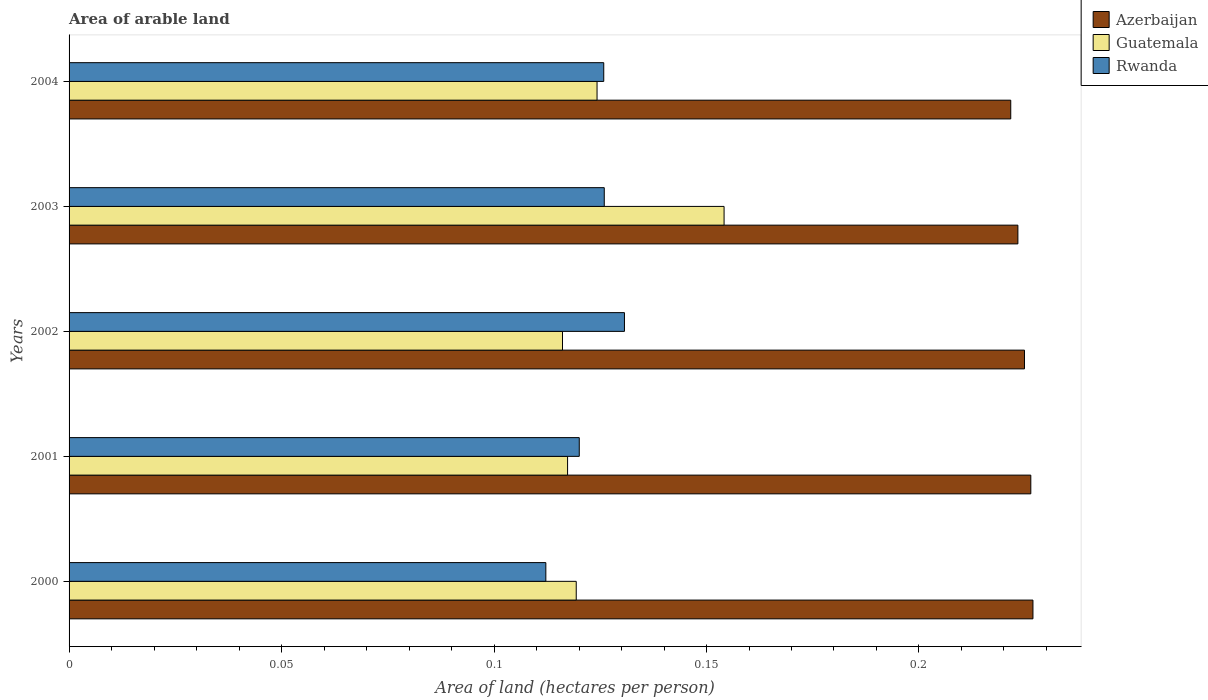How many different coloured bars are there?
Offer a terse response. 3. How many groups of bars are there?
Ensure brevity in your answer.  5. Are the number of bars per tick equal to the number of legend labels?
Give a very brief answer. Yes. Are the number of bars on each tick of the Y-axis equal?
Your answer should be very brief. Yes. How many bars are there on the 5th tick from the top?
Your answer should be very brief. 3. How many bars are there on the 5th tick from the bottom?
Offer a very short reply. 3. In how many cases, is the number of bars for a given year not equal to the number of legend labels?
Give a very brief answer. 0. What is the total arable land in Guatemala in 2001?
Keep it short and to the point. 0.12. Across all years, what is the maximum total arable land in Rwanda?
Keep it short and to the point. 0.13. Across all years, what is the minimum total arable land in Guatemala?
Offer a very short reply. 0.12. In which year was the total arable land in Guatemala minimum?
Offer a terse response. 2002. What is the total total arable land in Azerbaijan in the graph?
Offer a terse response. 1.12. What is the difference between the total arable land in Rwanda in 2000 and that in 2004?
Provide a succinct answer. -0.01. What is the difference between the total arable land in Rwanda in 2004 and the total arable land in Azerbaijan in 2001?
Provide a succinct answer. -0.1. What is the average total arable land in Guatemala per year?
Offer a terse response. 0.13. In the year 2004, what is the difference between the total arable land in Rwanda and total arable land in Azerbaijan?
Your response must be concise. -0.1. In how many years, is the total arable land in Azerbaijan greater than 0.12000000000000001 hectares per person?
Your answer should be very brief. 5. What is the ratio of the total arable land in Guatemala in 2000 to that in 2003?
Offer a very short reply. 0.77. Is the difference between the total arable land in Rwanda in 2000 and 2002 greater than the difference between the total arable land in Azerbaijan in 2000 and 2002?
Ensure brevity in your answer.  No. What is the difference between the highest and the second highest total arable land in Azerbaijan?
Your response must be concise. 0. What is the difference between the highest and the lowest total arable land in Guatemala?
Your answer should be compact. 0.04. Is the sum of the total arable land in Guatemala in 2000 and 2001 greater than the maximum total arable land in Rwanda across all years?
Give a very brief answer. Yes. What does the 2nd bar from the top in 2001 represents?
Your response must be concise. Guatemala. What does the 2nd bar from the bottom in 2001 represents?
Your answer should be compact. Guatemala. Is it the case that in every year, the sum of the total arable land in Azerbaijan and total arable land in Rwanda is greater than the total arable land in Guatemala?
Provide a succinct answer. Yes. How many bars are there?
Keep it short and to the point. 15. Are all the bars in the graph horizontal?
Offer a very short reply. Yes. What is the difference between two consecutive major ticks on the X-axis?
Give a very brief answer. 0.05. Does the graph contain any zero values?
Provide a short and direct response. No. Does the graph contain grids?
Your response must be concise. No. Where does the legend appear in the graph?
Provide a succinct answer. Top right. How are the legend labels stacked?
Provide a succinct answer. Vertical. What is the title of the graph?
Offer a terse response. Area of arable land. Does "Sierra Leone" appear as one of the legend labels in the graph?
Offer a terse response. No. What is the label or title of the X-axis?
Your answer should be very brief. Area of land (hectares per person). What is the Area of land (hectares per person) of Azerbaijan in 2000?
Give a very brief answer. 0.23. What is the Area of land (hectares per person) in Guatemala in 2000?
Your answer should be very brief. 0.12. What is the Area of land (hectares per person) of Rwanda in 2000?
Ensure brevity in your answer.  0.11. What is the Area of land (hectares per person) in Azerbaijan in 2001?
Offer a terse response. 0.23. What is the Area of land (hectares per person) in Guatemala in 2001?
Ensure brevity in your answer.  0.12. What is the Area of land (hectares per person) in Rwanda in 2001?
Ensure brevity in your answer.  0.12. What is the Area of land (hectares per person) of Azerbaijan in 2002?
Your response must be concise. 0.22. What is the Area of land (hectares per person) of Guatemala in 2002?
Provide a short and direct response. 0.12. What is the Area of land (hectares per person) of Rwanda in 2002?
Provide a short and direct response. 0.13. What is the Area of land (hectares per person) in Azerbaijan in 2003?
Your answer should be compact. 0.22. What is the Area of land (hectares per person) of Guatemala in 2003?
Your response must be concise. 0.15. What is the Area of land (hectares per person) in Rwanda in 2003?
Your answer should be very brief. 0.13. What is the Area of land (hectares per person) in Azerbaijan in 2004?
Provide a short and direct response. 0.22. What is the Area of land (hectares per person) in Guatemala in 2004?
Offer a terse response. 0.12. What is the Area of land (hectares per person) of Rwanda in 2004?
Provide a succinct answer. 0.13. Across all years, what is the maximum Area of land (hectares per person) of Azerbaijan?
Provide a short and direct response. 0.23. Across all years, what is the maximum Area of land (hectares per person) of Guatemala?
Your answer should be compact. 0.15. Across all years, what is the maximum Area of land (hectares per person) in Rwanda?
Offer a very short reply. 0.13. Across all years, what is the minimum Area of land (hectares per person) of Azerbaijan?
Offer a terse response. 0.22. Across all years, what is the minimum Area of land (hectares per person) of Guatemala?
Your answer should be very brief. 0.12. Across all years, what is the minimum Area of land (hectares per person) of Rwanda?
Keep it short and to the point. 0.11. What is the total Area of land (hectares per person) in Azerbaijan in the graph?
Your response must be concise. 1.12. What is the total Area of land (hectares per person) of Guatemala in the graph?
Ensure brevity in your answer.  0.63. What is the total Area of land (hectares per person) in Rwanda in the graph?
Offer a very short reply. 0.61. What is the difference between the Area of land (hectares per person) in Azerbaijan in 2000 and that in 2001?
Make the answer very short. 0. What is the difference between the Area of land (hectares per person) in Guatemala in 2000 and that in 2001?
Your response must be concise. 0. What is the difference between the Area of land (hectares per person) in Rwanda in 2000 and that in 2001?
Make the answer very short. -0.01. What is the difference between the Area of land (hectares per person) in Azerbaijan in 2000 and that in 2002?
Provide a succinct answer. 0. What is the difference between the Area of land (hectares per person) of Guatemala in 2000 and that in 2002?
Give a very brief answer. 0. What is the difference between the Area of land (hectares per person) in Rwanda in 2000 and that in 2002?
Keep it short and to the point. -0.02. What is the difference between the Area of land (hectares per person) in Azerbaijan in 2000 and that in 2003?
Provide a short and direct response. 0. What is the difference between the Area of land (hectares per person) in Guatemala in 2000 and that in 2003?
Provide a short and direct response. -0.03. What is the difference between the Area of land (hectares per person) of Rwanda in 2000 and that in 2003?
Give a very brief answer. -0.01. What is the difference between the Area of land (hectares per person) in Azerbaijan in 2000 and that in 2004?
Your answer should be very brief. 0.01. What is the difference between the Area of land (hectares per person) in Guatemala in 2000 and that in 2004?
Provide a succinct answer. -0. What is the difference between the Area of land (hectares per person) in Rwanda in 2000 and that in 2004?
Make the answer very short. -0.01. What is the difference between the Area of land (hectares per person) of Azerbaijan in 2001 and that in 2002?
Ensure brevity in your answer.  0. What is the difference between the Area of land (hectares per person) of Guatemala in 2001 and that in 2002?
Your answer should be very brief. 0. What is the difference between the Area of land (hectares per person) of Rwanda in 2001 and that in 2002?
Your response must be concise. -0.01. What is the difference between the Area of land (hectares per person) in Azerbaijan in 2001 and that in 2003?
Offer a terse response. 0. What is the difference between the Area of land (hectares per person) of Guatemala in 2001 and that in 2003?
Offer a very short reply. -0.04. What is the difference between the Area of land (hectares per person) in Rwanda in 2001 and that in 2003?
Offer a terse response. -0.01. What is the difference between the Area of land (hectares per person) in Azerbaijan in 2001 and that in 2004?
Your answer should be compact. 0. What is the difference between the Area of land (hectares per person) of Guatemala in 2001 and that in 2004?
Your answer should be compact. -0.01. What is the difference between the Area of land (hectares per person) in Rwanda in 2001 and that in 2004?
Offer a very short reply. -0.01. What is the difference between the Area of land (hectares per person) of Azerbaijan in 2002 and that in 2003?
Provide a short and direct response. 0. What is the difference between the Area of land (hectares per person) of Guatemala in 2002 and that in 2003?
Give a very brief answer. -0.04. What is the difference between the Area of land (hectares per person) in Rwanda in 2002 and that in 2003?
Your answer should be compact. 0. What is the difference between the Area of land (hectares per person) in Azerbaijan in 2002 and that in 2004?
Keep it short and to the point. 0. What is the difference between the Area of land (hectares per person) in Guatemala in 2002 and that in 2004?
Your answer should be very brief. -0.01. What is the difference between the Area of land (hectares per person) in Rwanda in 2002 and that in 2004?
Your answer should be compact. 0. What is the difference between the Area of land (hectares per person) of Azerbaijan in 2003 and that in 2004?
Keep it short and to the point. 0. What is the difference between the Area of land (hectares per person) in Guatemala in 2003 and that in 2004?
Your answer should be compact. 0.03. What is the difference between the Area of land (hectares per person) in Rwanda in 2003 and that in 2004?
Your answer should be very brief. 0. What is the difference between the Area of land (hectares per person) of Azerbaijan in 2000 and the Area of land (hectares per person) of Guatemala in 2001?
Offer a terse response. 0.11. What is the difference between the Area of land (hectares per person) in Azerbaijan in 2000 and the Area of land (hectares per person) in Rwanda in 2001?
Your answer should be very brief. 0.11. What is the difference between the Area of land (hectares per person) of Guatemala in 2000 and the Area of land (hectares per person) of Rwanda in 2001?
Provide a succinct answer. -0. What is the difference between the Area of land (hectares per person) in Azerbaijan in 2000 and the Area of land (hectares per person) in Guatemala in 2002?
Make the answer very short. 0.11. What is the difference between the Area of land (hectares per person) of Azerbaijan in 2000 and the Area of land (hectares per person) of Rwanda in 2002?
Ensure brevity in your answer.  0.1. What is the difference between the Area of land (hectares per person) of Guatemala in 2000 and the Area of land (hectares per person) of Rwanda in 2002?
Your response must be concise. -0.01. What is the difference between the Area of land (hectares per person) in Azerbaijan in 2000 and the Area of land (hectares per person) in Guatemala in 2003?
Your response must be concise. 0.07. What is the difference between the Area of land (hectares per person) of Azerbaijan in 2000 and the Area of land (hectares per person) of Rwanda in 2003?
Offer a terse response. 0.1. What is the difference between the Area of land (hectares per person) of Guatemala in 2000 and the Area of land (hectares per person) of Rwanda in 2003?
Provide a succinct answer. -0.01. What is the difference between the Area of land (hectares per person) in Azerbaijan in 2000 and the Area of land (hectares per person) in Guatemala in 2004?
Ensure brevity in your answer.  0.1. What is the difference between the Area of land (hectares per person) in Azerbaijan in 2000 and the Area of land (hectares per person) in Rwanda in 2004?
Provide a short and direct response. 0.1. What is the difference between the Area of land (hectares per person) in Guatemala in 2000 and the Area of land (hectares per person) in Rwanda in 2004?
Keep it short and to the point. -0.01. What is the difference between the Area of land (hectares per person) in Azerbaijan in 2001 and the Area of land (hectares per person) in Guatemala in 2002?
Provide a succinct answer. 0.11. What is the difference between the Area of land (hectares per person) in Azerbaijan in 2001 and the Area of land (hectares per person) in Rwanda in 2002?
Provide a short and direct response. 0.1. What is the difference between the Area of land (hectares per person) of Guatemala in 2001 and the Area of land (hectares per person) of Rwanda in 2002?
Make the answer very short. -0.01. What is the difference between the Area of land (hectares per person) in Azerbaijan in 2001 and the Area of land (hectares per person) in Guatemala in 2003?
Your response must be concise. 0.07. What is the difference between the Area of land (hectares per person) of Azerbaijan in 2001 and the Area of land (hectares per person) of Rwanda in 2003?
Your response must be concise. 0.1. What is the difference between the Area of land (hectares per person) in Guatemala in 2001 and the Area of land (hectares per person) in Rwanda in 2003?
Make the answer very short. -0.01. What is the difference between the Area of land (hectares per person) of Azerbaijan in 2001 and the Area of land (hectares per person) of Guatemala in 2004?
Provide a succinct answer. 0.1. What is the difference between the Area of land (hectares per person) of Azerbaijan in 2001 and the Area of land (hectares per person) of Rwanda in 2004?
Offer a terse response. 0.1. What is the difference between the Area of land (hectares per person) of Guatemala in 2001 and the Area of land (hectares per person) of Rwanda in 2004?
Your response must be concise. -0.01. What is the difference between the Area of land (hectares per person) of Azerbaijan in 2002 and the Area of land (hectares per person) of Guatemala in 2003?
Your response must be concise. 0.07. What is the difference between the Area of land (hectares per person) of Azerbaijan in 2002 and the Area of land (hectares per person) of Rwanda in 2003?
Your response must be concise. 0.1. What is the difference between the Area of land (hectares per person) in Guatemala in 2002 and the Area of land (hectares per person) in Rwanda in 2003?
Your answer should be very brief. -0.01. What is the difference between the Area of land (hectares per person) of Azerbaijan in 2002 and the Area of land (hectares per person) of Guatemala in 2004?
Give a very brief answer. 0.1. What is the difference between the Area of land (hectares per person) in Azerbaijan in 2002 and the Area of land (hectares per person) in Rwanda in 2004?
Provide a succinct answer. 0.1. What is the difference between the Area of land (hectares per person) in Guatemala in 2002 and the Area of land (hectares per person) in Rwanda in 2004?
Your answer should be compact. -0.01. What is the difference between the Area of land (hectares per person) of Azerbaijan in 2003 and the Area of land (hectares per person) of Guatemala in 2004?
Provide a succinct answer. 0.1. What is the difference between the Area of land (hectares per person) in Azerbaijan in 2003 and the Area of land (hectares per person) in Rwanda in 2004?
Your answer should be very brief. 0.1. What is the difference between the Area of land (hectares per person) in Guatemala in 2003 and the Area of land (hectares per person) in Rwanda in 2004?
Your answer should be compact. 0.03. What is the average Area of land (hectares per person) of Azerbaijan per year?
Your answer should be compact. 0.22. What is the average Area of land (hectares per person) in Guatemala per year?
Offer a terse response. 0.13. What is the average Area of land (hectares per person) in Rwanda per year?
Offer a terse response. 0.12. In the year 2000, what is the difference between the Area of land (hectares per person) of Azerbaijan and Area of land (hectares per person) of Guatemala?
Your response must be concise. 0.11. In the year 2000, what is the difference between the Area of land (hectares per person) in Azerbaijan and Area of land (hectares per person) in Rwanda?
Offer a terse response. 0.11. In the year 2000, what is the difference between the Area of land (hectares per person) in Guatemala and Area of land (hectares per person) in Rwanda?
Provide a short and direct response. 0.01. In the year 2001, what is the difference between the Area of land (hectares per person) of Azerbaijan and Area of land (hectares per person) of Guatemala?
Your answer should be very brief. 0.11. In the year 2001, what is the difference between the Area of land (hectares per person) in Azerbaijan and Area of land (hectares per person) in Rwanda?
Ensure brevity in your answer.  0.11. In the year 2001, what is the difference between the Area of land (hectares per person) in Guatemala and Area of land (hectares per person) in Rwanda?
Your answer should be compact. -0. In the year 2002, what is the difference between the Area of land (hectares per person) in Azerbaijan and Area of land (hectares per person) in Guatemala?
Your answer should be very brief. 0.11. In the year 2002, what is the difference between the Area of land (hectares per person) of Azerbaijan and Area of land (hectares per person) of Rwanda?
Your response must be concise. 0.09. In the year 2002, what is the difference between the Area of land (hectares per person) of Guatemala and Area of land (hectares per person) of Rwanda?
Give a very brief answer. -0.01. In the year 2003, what is the difference between the Area of land (hectares per person) in Azerbaijan and Area of land (hectares per person) in Guatemala?
Provide a succinct answer. 0.07. In the year 2003, what is the difference between the Area of land (hectares per person) in Azerbaijan and Area of land (hectares per person) in Rwanda?
Provide a short and direct response. 0.1. In the year 2003, what is the difference between the Area of land (hectares per person) in Guatemala and Area of land (hectares per person) in Rwanda?
Provide a short and direct response. 0.03. In the year 2004, what is the difference between the Area of land (hectares per person) of Azerbaijan and Area of land (hectares per person) of Guatemala?
Offer a terse response. 0.1. In the year 2004, what is the difference between the Area of land (hectares per person) of Azerbaijan and Area of land (hectares per person) of Rwanda?
Your response must be concise. 0.1. In the year 2004, what is the difference between the Area of land (hectares per person) in Guatemala and Area of land (hectares per person) in Rwanda?
Provide a short and direct response. -0. What is the ratio of the Area of land (hectares per person) of Guatemala in 2000 to that in 2001?
Provide a short and direct response. 1.02. What is the ratio of the Area of land (hectares per person) of Rwanda in 2000 to that in 2001?
Keep it short and to the point. 0.93. What is the ratio of the Area of land (hectares per person) in Azerbaijan in 2000 to that in 2002?
Your answer should be compact. 1.01. What is the ratio of the Area of land (hectares per person) of Guatemala in 2000 to that in 2002?
Give a very brief answer. 1.03. What is the ratio of the Area of land (hectares per person) of Rwanda in 2000 to that in 2002?
Your answer should be compact. 0.86. What is the ratio of the Area of land (hectares per person) in Azerbaijan in 2000 to that in 2003?
Your response must be concise. 1.02. What is the ratio of the Area of land (hectares per person) in Guatemala in 2000 to that in 2003?
Your answer should be very brief. 0.77. What is the ratio of the Area of land (hectares per person) in Rwanda in 2000 to that in 2003?
Your answer should be very brief. 0.89. What is the ratio of the Area of land (hectares per person) of Azerbaijan in 2000 to that in 2004?
Your answer should be compact. 1.02. What is the ratio of the Area of land (hectares per person) of Guatemala in 2000 to that in 2004?
Your answer should be very brief. 0.96. What is the ratio of the Area of land (hectares per person) in Rwanda in 2000 to that in 2004?
Keep it short and to the point. 0.89. What is the ratio of the Area of land (hectares per person) in Azerbaijan in 2001 to that in 2002?
Your answer should be compact. 1.01. What is the ratio of the Area of land (hectares per person) of Guatemala in 2001 to that in 2002?
Ensure brevity in your answer.  1.01. What is the ratio of the Area of land (hectares per person) in Rwanda in 2001 to that in 2002?
Offer a terse response. 0.92. What is the ratio of the Area of land (hectares per person) of Azerbaijan in 2001 to that in 2003?
Offer a very short reply. 1.01. What is the ratio of the Area of land (hectares per person) in Guatemala in 2001 to that in 2003?
Your response must be concise. 0.76. What is the ratio of the Area of land (hectares per person) in Rwanda in 2001 to that in 2003?
Ensure brevity in your answer.  0.95. What is the ratio of the Area of land (hectares per person) of Azerbaijan in 2001 to that in 2004?
Ensure brevity in your answer.  1.02. What is the ratio of the Area of land (hectares per person) in Guatemala in 2001 to that in 2004?
Give a very brief answer. 0.94. What is the ratio of the Area of land (hectares per person) in Rwanda in 2001 to that in 2004?
Provide a succinct answer. 0.95. What is the ratio of the Area of land (hectares per person) of Guatemala in 2002 to that in 2003?
Provide a succinct answer. 0.75. What is the ratio of the Area of land (hectares per person) of Rwanda in 2002 to that in 2003?
Offer a very short reply. 1.04. What is the ratio of the Area of land (hectares per person) of Azerbaijan in 2002 to that in 2004?
Your answer should be very brief. 1.01. What is the ratio of the Area of land (hectares per person) in Guatemala in 2002 to that in 2004?
Make the answer very short. 0.93. What is the ratio of the Area of land (hectares per person) in Rwanda in 2002 to that in 2004?
Offer a terse response. 1.04. What is the ratio of the Area of land (hectares per person) in Azerbaijan in 2003 to that in 2004?
Your answer should be very brief. 1.01. What is the ratio of the Area of land (hectares per person) in Guatemala in 2003 to that in 2004?
Give a very brief answer. 1.24. What is the difference between the highest and the second highest Area of land (hectares per person) of Guatemala?
Provide a short and direct response. 0.03. What is the difference between the highest and the second highest Area of land (hectares per person) of Rwanda?
Keep it short and to the point. 0. What is the difference between the highest and the lowest Area of land (hectares per person) of Azerbaijan?
Provide a short and direct response. 0.01. What is the difference between the highest and the lowest Area of land (hectares per person) in Guatemala?
Keep it short and to the point. 0.04. What is the difference between the highest and the lowest Area of land (hectares per person) in Rwanda?
Provide a short and direct response. 0.02. 